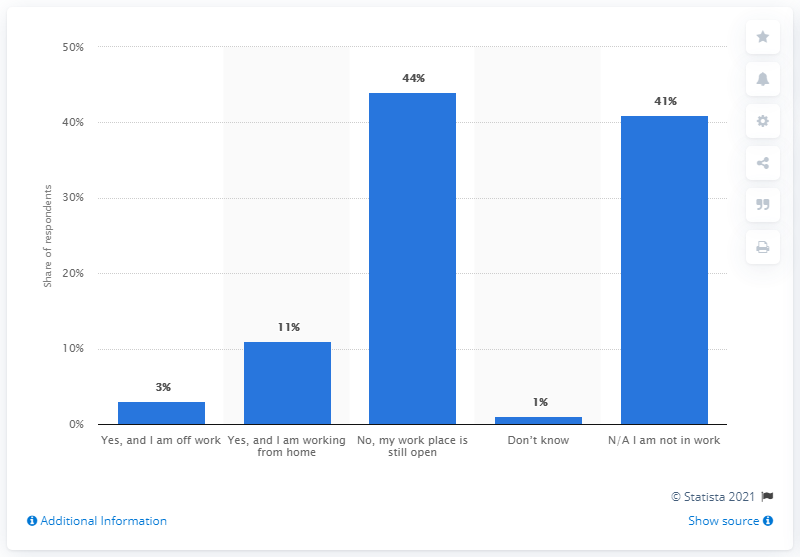Identify some key points in this picture. As of March 17, 2020, it was reported that approximately 11% of people in Great Britain were working from home. 